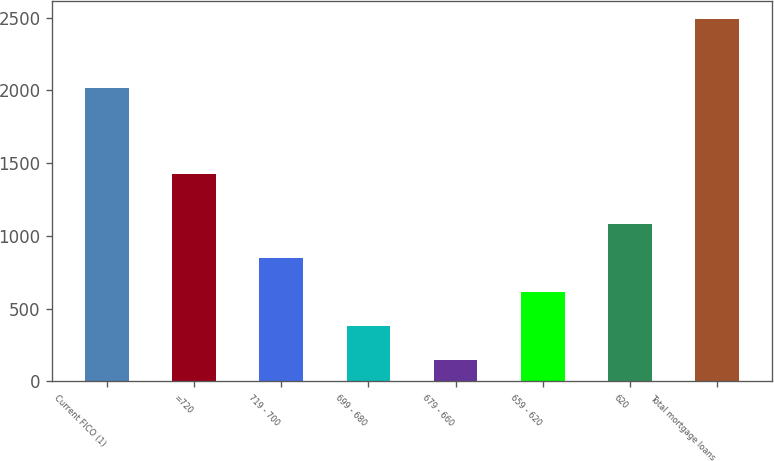Convert chart to OTSL. <chart><loc_0><loc_0><loc_500><loc_500><bar_chart><fcel>Current FICO (1)<fcel>=720<fcel>719 - 700<fcel>699 - 680<fcel>679 - 660<fcel>659 - 620<fcel>620<fcel>Total mortgage loans<nl><fcel>2015<fcel>1423<fcel>851.4<fcel>383.8<fcel>150<fcel>617.6<fcel>1085.2<fcel>2488<nl></chart> 